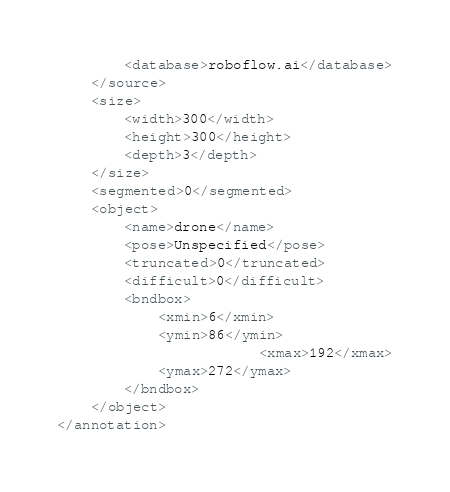<code> <loc_0><loc_0><loc_500><loc_500><_XML_>		<database>roboflow.ai</database>
	</source>
	<size>
		<width>300</width>
		<height>300</height>
		<depth>3</depth>
	</size>
	<segmented>0</segmented>
	<object>
		<name>drone</name>
		<pose>Unspecified</pose>
		<truncated>0</truncated>
		<difficult>0</difficult>
		<bndbox>
			<xmin>6</xmin>
			<ymin>86</ymin>
                        <xmax>192</xmax>
			<ymax>272</ymax>
		</bndbox>
	</object>
</annotation>
</code> 